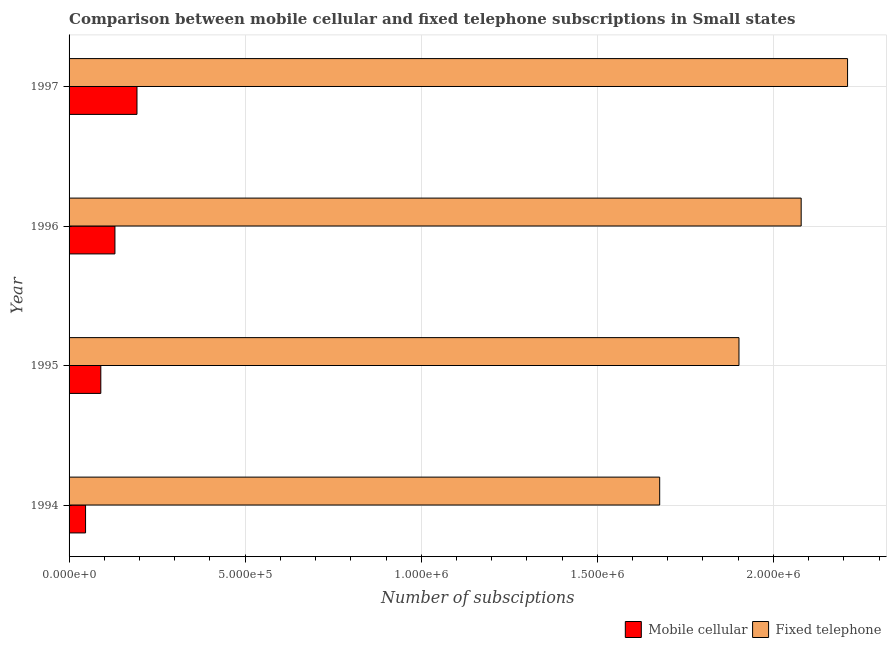How many groups of bars are there?
Give a very brief answer. 4. In how many cases, is the number of bars for a given year not equal to the number of legend labels?
Provide a succinct answer. 0. What is the number of mobile cellular subscriptions in 1996?
Offer a very short reply. 1.30e+05. Across all years, what is the maximum number of mobile cellular subscriptions?
Offer a terse response. 1.93e+05. Across all years, what is the minimum number of fixed telephone subscriptions?
Make the answer very short. 1.68e+06. In which year was the number of fixed telephone subscriptions maximum?
Ensure brevity in your answer.  1997. What is the total number of mobile cellular subscriptions in the graph?
Keep it short and to the point. 4.60e+05. What is the difference between the number of mobile cellular subscriptions in 1994 and that in 1995?
Give a very brief answer. -4.33e+04. What is the difference between the number of mobile cellular subscriptions in 1997 and the number of fixed telephone subscriptions in 1996?
Provide a succinct answer. -1.89e+06. What is the average number of mobile cellular subscriptions per year?
Give a very brief answer. 1.15e+05. In the year 1994, what is the difference between the number of fixed telephone subscriptions and number of mobile cellular subscriptions?
Give a very brief answer. 1.63e+06. In how many years, is the number of mobile cellular subscriptions greater than 1600000 ?
Your answer should be compact. 0. What is the ratio of the number of mobile cellular subscriptions in 1994 to that in 1995?
Give a very brief answer. 0.52. Is the difference between the number of fixed telephone subscriptions in 1996 and 1997 greater than the difference between the number of mobile cellular subscriptions in 1996 and 1997?
Offer a very short reply. No. What is the difference between the highest and the second highest number of fixed telephone subscriptions?
Offer a very short reply. 1.32e+05. What is the difference between the highest and the lowest number of fixed telephone subscriptions?
Your answer should be very brief. 5.34e+05. In how many years, is the number of fixed telephone subscriptions greater than the average number of fixed telephone subscriptions taken over all years?
Give a very brief answer. 2. Is the sum of the number of fixed telephone subscriptions in 1995 and 1997 greater than the maximum number of mobile cellular subscriptions across all years?
Ensure brevity in your answer.  Yes. What does the 1st bar from the top in 1994 represents?
Give a very brief answer. Fixed telephone. What does the 2nd bar from the bottom in 1994 represents?
Your answer should be very brief. Fixed telephone. Are all the bars in the graph horizontal?
Keep it short and to the point. Yes. Are the values on the major ticks of X-axis written in scientific E-notation?
Offer a terse response. Yes. Does the graph contain grids?
Give a very brief answer. Yes. Where does the legend appear in the graph?
Provide a succinct answer. Bottom right. How are the legend labels stacked?
Your answer should be compact. Horizontal. What is the title of the graph?
Offer a very short reply. Comparison between mobile cellular and fixed telephone subscriptions in Small states. Does "Measles" appear as one of the legend labels in the graph?
Ensure brevity in your answer.  No. What is the label or title of the X-axis?
Your response must be concise. Number of subsciptions. What is the Number of subsciptions of Mobile cellular in 1994?
Provide a succinct answer. 4.68e+04. What is the Number of subsciptions in Fixed telephone in 1994?
Offer a very short reply. 1.68e+06. What is the Number of subsciptions of Mobile cellular in 1995?
Make the answer very short. 9.01e+04. What is the Number of subsciptions of Fixed telephone in 1995?
Make the answer very short. 1.90e+06. What is the Number of subsciptions of Mobile cellular in 1996?
Make the answer very short. 1.30e+05. What is the Number of subsciptions of Fixed telephone in 1996?
Offer a very short reply. 2.08e+06. What is the Number of subsciptions of Mobile cellular in 1997?
Offer a very short reply. 1.93e+05. What is the Number of subsciptions in Fixed telephone in 1997?
Offer a terse response. 2.21e+06. Across all years, what is the maximum Number of subsciptions in Mobile cellular?
Make the answer very short. 1.93e+05. Across all years, what is the maximum Number of subsciptions of Fixed telephone?
Your answer should be very brief. 2.21e+06. Across all years, what is the minimum Number of subsciptions in Mobile cellular?
Your response must be concise. 4.68e+04. Across all years, what is the minimum Number of subsciptions in Fixed telephone?
Make the answer very short. 1.68e+06. What is the total Number of subsciptions of Mobile cellular in the graph?
Your answer should be very brief. 4.60e+05. What is the total Number of subsciptions of Fixed telephone in the graph?
Offer a very short reply. 7.87e+06. What is the difference between the Number of subsciptions of Mobile cellular in 1994 and that in 1995?
Offer a terse response. -4.33e+04. What is the difference between the Number of subsciptions in Fixed telephone in 1994 and that in 1995?
Provide a succinct answer. -2.25e+05. What is the difference between the Number of subsciptions in Mobile cellular in 1994 and that in 1996?
Ensure brevity in your answer.  -8.34e+04. What is the difference between the Number of subsciptions in Fixed telephone in 1994 and that in 1996?
Your answer should be compact. -4.02e+05. What is the difference between the Number of subsciptions of Mobile cellular in 1994 and that in 1997?
Offer a very short reply. -1.46e+05. What is the difference between the Number of subsciptions of Fixed telephone in 1994 and that in 1997?
Give a very brief answer. -5.34e+05. What is the difference between the Number of subsciptions of Mobile cellular in 1995 and that in 1996?
Keep it short and to the point. -4.01e+04. What is the difference between the Number of subsciptions of Fixed telephone in 1995 and that in 1996?
Your response must be concise. -1.77e+05. What is the difference between the Number of subsciptions in Mobile cellular in 1995 and that in 1997?
Make the answer very short. -1.03e+05. What is the difference between the Number of subsciptions of Fixed telephone in 1995 and that in 1997?
Keep it short and to the point. -3.08e+05. What is the difference between the Number of subsciptions in Mobile cellular in 1996 and that in 1997?
Offer a terse response. -6.26e+04. What is the difference between the Number of subsciptions in Fixed telephone in 1996 and that in 1997?
Offer a terse response. -1.32e+05. What is the difference between the Number of subsciptions in Mobile cellular in 1994 and the Number of subsciptions in Fixed telephone in 1995?
Make the answer very short. -1.86e+06. What is the difference between the Number of subsciptions in Mobile cellular in 1994 and the Number of subsciptions in Fixed telephone in 1996?
Give a very brief answer. -2.03e+06. What is the difference between the Number of subsciptions of Mobile cellular in 1994 and the Number of subsciptions of Fixed telephone in 1997?
Your answer should be very brief. -2.16e+06. What is the difference between the Number of subsciptions in Mobile cellular in 1995 and the Number of subsciptions in Fixed telephone in 1996?
Keep it short and to the point. -1.99e+06. What is the difference between the Number of subsciptions in Mobile cellular in 1995 and the Number of subsciptions in Fixed telephone in 1997?
Your answer should be compact. -2.12e+06. What is the difference between the Number of subsciptions in Mobile cellular in 1996 and the Number of subsciptions in Fixed telephone in 1997?
Make the answer very short. -2.08e+06. What is the average Number of subsciptions in Mobile cellular per year?
Offer a very short reply. 1.15e+05. What is the average Number of subsciptions of Fixed telephone per year?
Provide a succinct answer. 1.97e+06. In the year 1994, what is the difference between the Number of subsciptions in Mobile cellular and Number of subsciptions in Fixed telephone?
Offer a terse response. -1.63e+06. In the year 1995, what is the difference between the Number of subsciptions of Mobile cellular and Number of subsciptions of Fixed telephone?
Ensure brevity in your answer.  -1.81e+06. In the year 1996, what is the difference between the Number of subsciptions in Mobile cellular and Number of subsciptions in Fixed telephone?
Keep it short and to the point. -1.95e+06. In the year 1997, what is the difference between the Number of subsciptions in Mobile cellular and Number of subsciptions in Fixed telephone?
Your answer should be compact. -2.02e+06. What is the ratio of the Number of subsciptions of Mobile cellular in 1994 to that in 1995?
Provide a short and direct response. 0.52. What is the ratio of the Number of subsciptions in Fixed telephone in 1994 to that in 1995?
Provide a succinct answer. 0.88. What is the ratio of the Number of subsciptions in Mobile cellular in 1994 to that in 1996?
Keep it short and to the point. 0.36. What is the ratio of the Number of subsciptions in Fixed telephone in 1994 to that in 1996?
Provide a short and direct response. 0.81. What is the ratio of the Number of subsciptions of Mobile cellular in 1994 to that in 1997?
Keep it short and to the point. 0.24. What is the ratio of the Number of subsciptions of Fixed telephone in 1994 to that in 1997?
Ensure brevity in your answer.  0.76. What is the ratio of the Number of subsciptions in Mobile cellular in 1995 to that in 1996?
Give a very brief answer. 0.69. What is the ratio of the Number of subsciptions of Fixed telephone in 1995 to that in 1996?
Provide a short and direct response. 0.92. What is the ratio of the Number of subsciptions of Mobile cellular in 1995 to that in 1997?
Offer a very short reply. 0.47. What is the ratio of the Number of subsciptions in Fixed telephone in 1995 to that in 1997?
Your response must be concise. 0.86. What is the ratio of the Number of subsciptions of Mobile cellular in 1996 to that in 1997?
Your answer should be very brief. 0.68. What is the ratio of the Number of subsciptions of Fixed telephone in 1996 to that in 1997?
Your answer should be very brief. 0.94. What is the difference between the highest and the second highest Number of subsciptions in Mobile cellular?
Your answer should be compact. 6.26e+04. What is the difference between the highest and the second highest Number of subsciptions in Fixed telephone?
Give a very brief answer. 1.32e+05. What is the difference between the highest and the lowest Number of subsciptions of Mobile cellular?
Offer a very short reply. 1.46e+05. What is the difference between the highest and the lowest Number of subsciptions of Fixed telephone?
Give a very brief answer. 5.34e+05. 